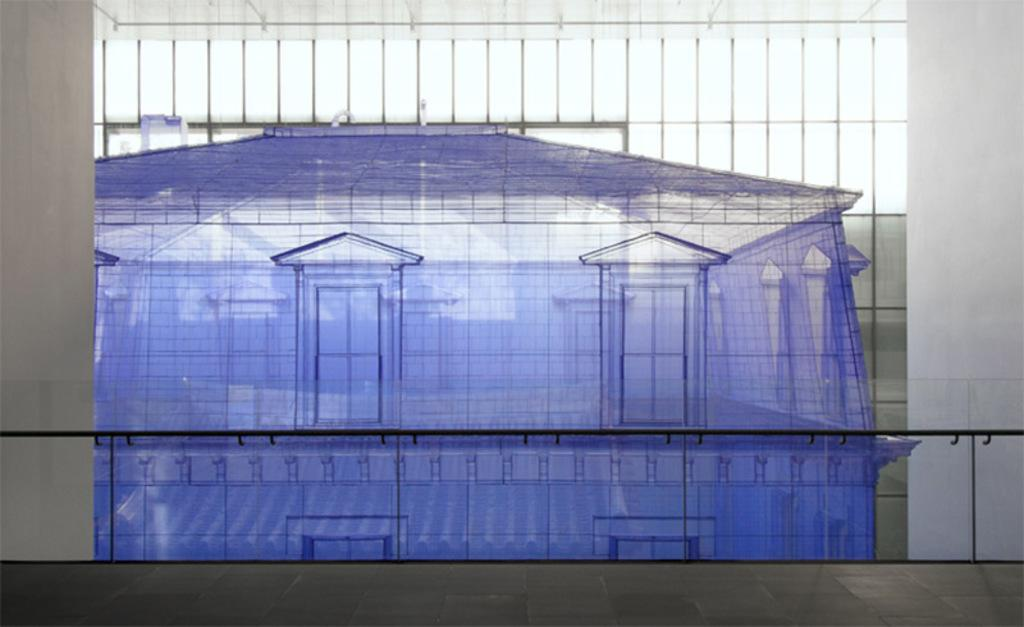What type of document is shown in the image? There is a blueprint of a building in the image. What architectural feature can be seen in the image? There is a window visible in the image. What structural element is present in the image? There is a wall visible in the image. Can you tell me how many balls are rolling down the street in the image? There are no balls or streets present in the image; it features a blueprint of a building with a window and a wall. 